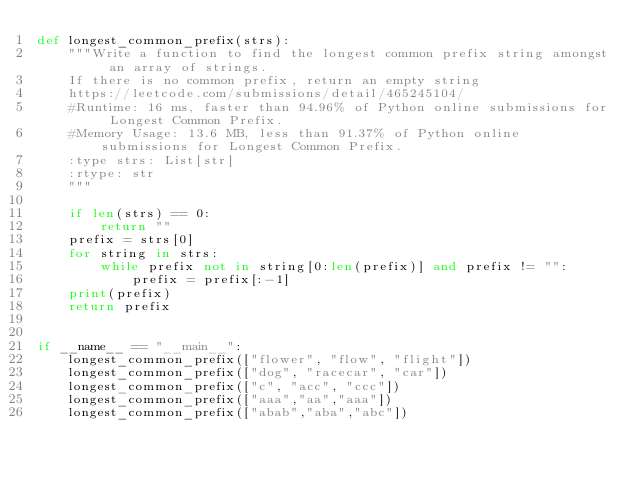<code> <loc_0><loc_0><loc_500><loc_500><_Python_>def longest_common_prefix(strs):
    """Write a function to find the longest common prefix string amongst an array of strings.
    If there is no common prefix, return an empty string
    https://leetcode.com/submissions/detail/465245104/
    #Runtime: 16 ms, faster than 94.96% of Python online submissions for Longest Common Prefix.
    #Memory Usage: 13.6 MB, less than 91.37% of Python online submissions for Longest Common Prefix.
    :type strs: List[str]
    :rtype: str
    """

    if len(strs) == 0:
        return ""
    prefix = strs[0]
    for string in strs:
        while prefix not in string[0:len(prefix)] and prefix != "":
            prefix = prefix[:-1]
    print(prefix)
    return prefix


if __name__ == "__main__":
    longest_common_prefix(["flower", "flow", "flight"])
    longest_common_prefix(["dog", "racecar", "car"])
    longest_common_prefix(["c", "acc", "ccc"])
    longest_common_prefix(["aaa","aa","aaa"])
    longest_common_prefix(["abab","aba","abc"])

</code> 